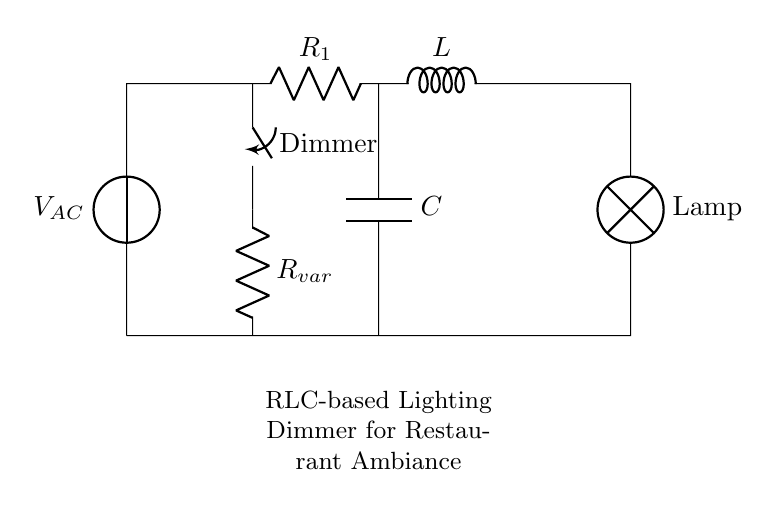What are the components in the circuit? The circuit comprises a voltage source, a resistor, an inductor, a capacitor, a lamp, and a dimmer switch. Each of these components plays a role in regulating the lighting.
Answer: Voltage source, resistor, inductor, capacitor, lamp, dimmer switch What is the function of the dimmer switch? The dimmer switch controls the amount of voltage that reaches the lamp by adjusting the resistance, thereby altering the brightness.
Answer: To adjust brightness How many resistors are present in the circuit? There are two resistors indicated in the circuit: the main resistor labeled as R and a variable resistor labeled as R_var.
Answer: Two What is the role of the inductor in the circuit? The inductor stores energy in a magnetic field when current flows through it, which helps stabilize and smooth out the current supplied to the lamp.
Answer: Energy storage How does changing the variable resistor affect the circuit? Adjusting the variable resistor changes the resistance and consequently alters the current through the circuit, which directly influences the brightness of the lamp. This is because more resistance reduces current, dimming the light, while less resistance allows more current, brightening the light.
Answer: Changes brightness What type of circuit is this RLC circuit classified as? This circuit is classified as an RLC circuit because it contains a resistor (R), an inductor (L), and a capacitor (C) connected in series, which all contribute to its dynamic response to changing voltage.
Answer: RLC circuit What is the main purpose of this circuit in a restaurant setting? The main purpose is to create ambiance by dimming the lighting in the restaurant or bar to fit different moods or times of day, enhancing the customer experience.
Answer: To create ambiance 